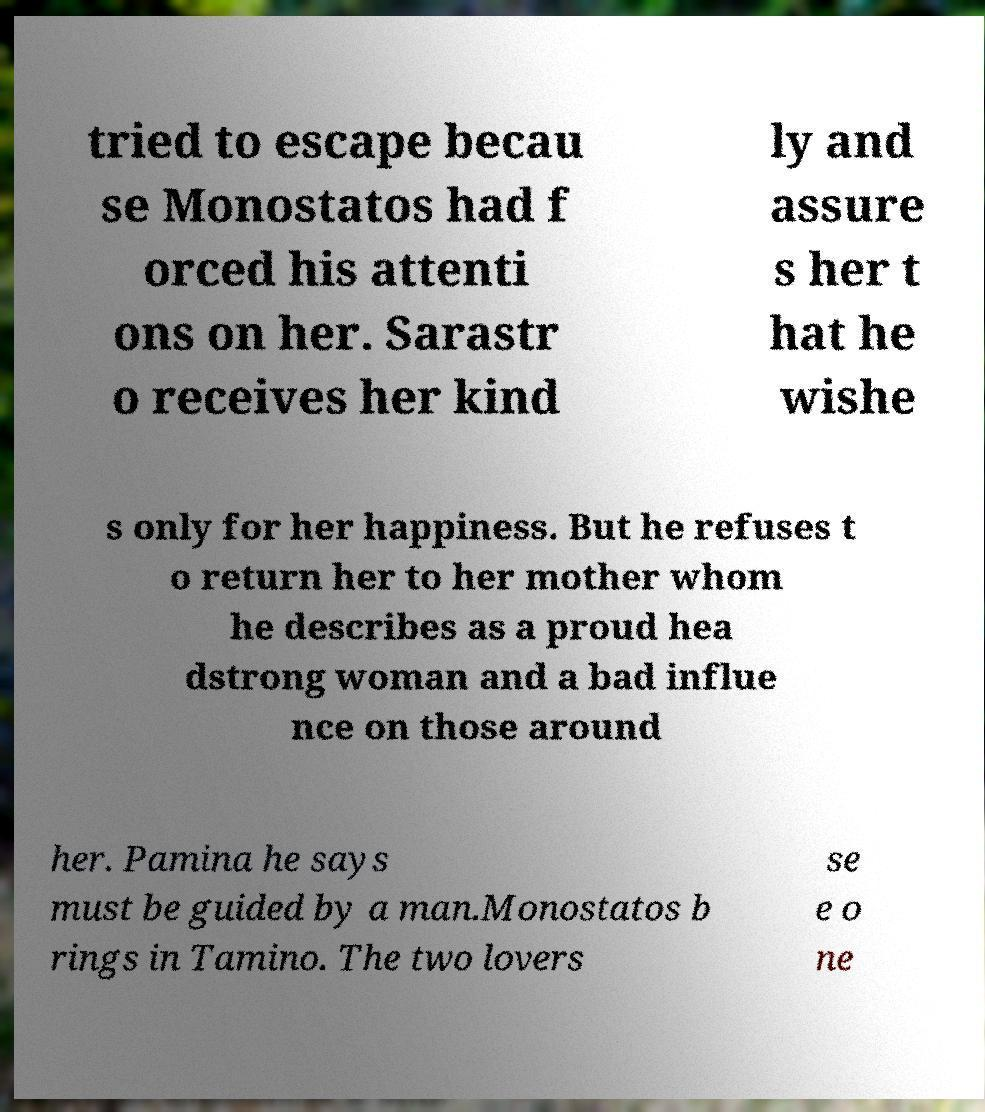Could you extract and type out the text from this image? tried to escape becau se Monostatos had f orced his attenti ons on her. Sarastr o receives her kind ly and assure s her t hat he wishe s only for her happiness. But he refuses t o return her to her mother whom he describes as a proud hea dstrong woman and a bad influe nce on those around her. Pamina he says must be guided by a man.Monostatos b rings in Tamino. The two lovers se e o ne 